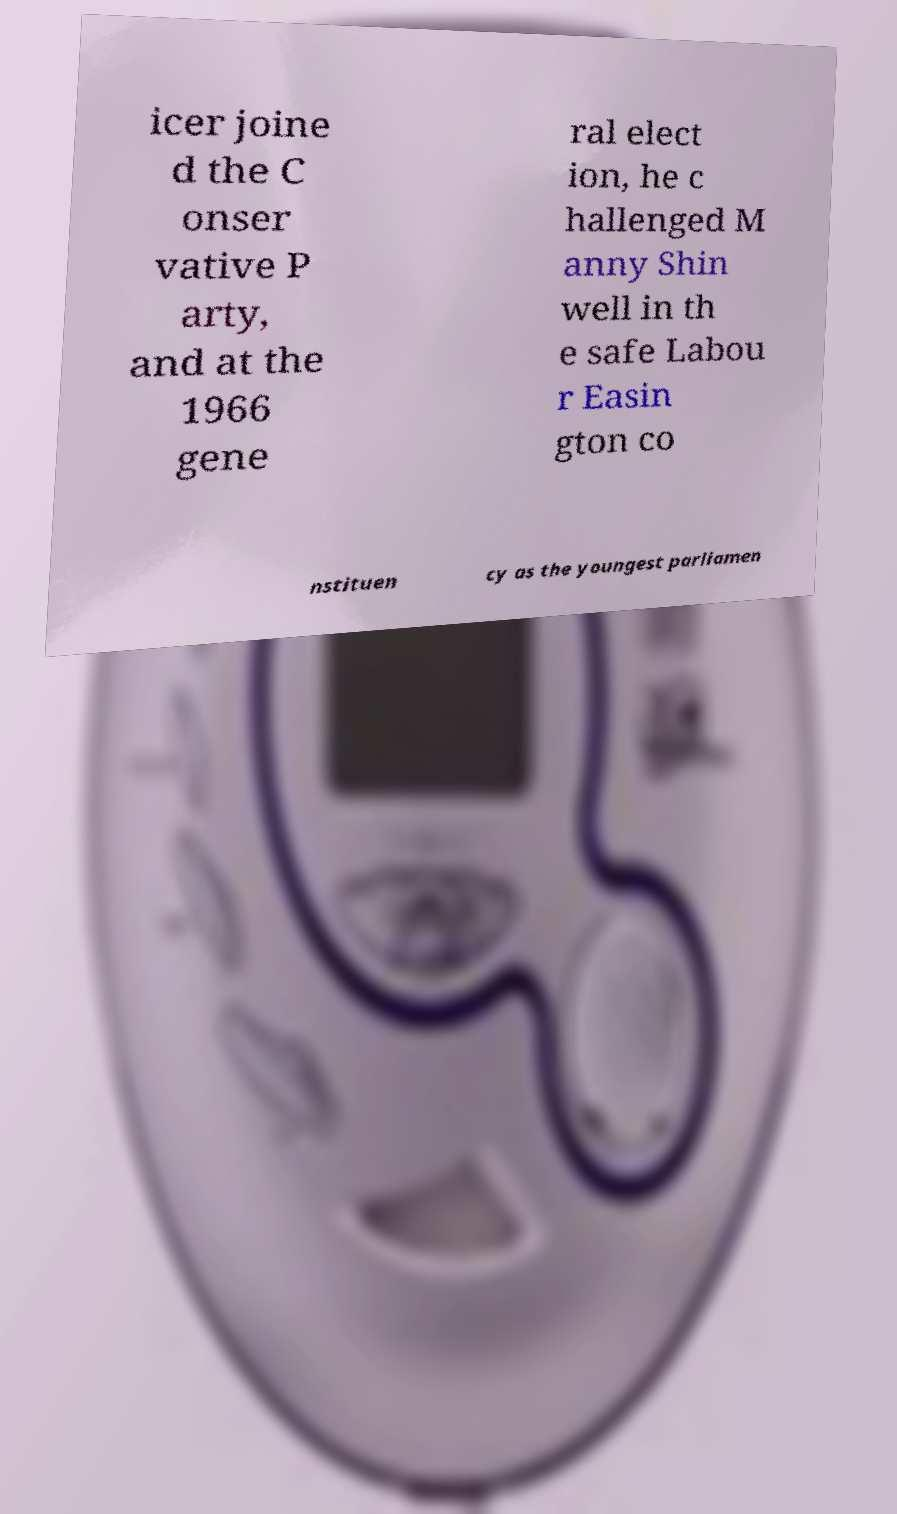Can you read and provide the text displayed in the image?This photo seems to have some interesting text. Can you extract and type it out for me? icer joine d the C onser vative P arty, and at the 1966 gene ral elect ion, he c hallenged M anny Shin well in th e safe Labou r Easin gton co nstituen cy as the youngest parliamen 